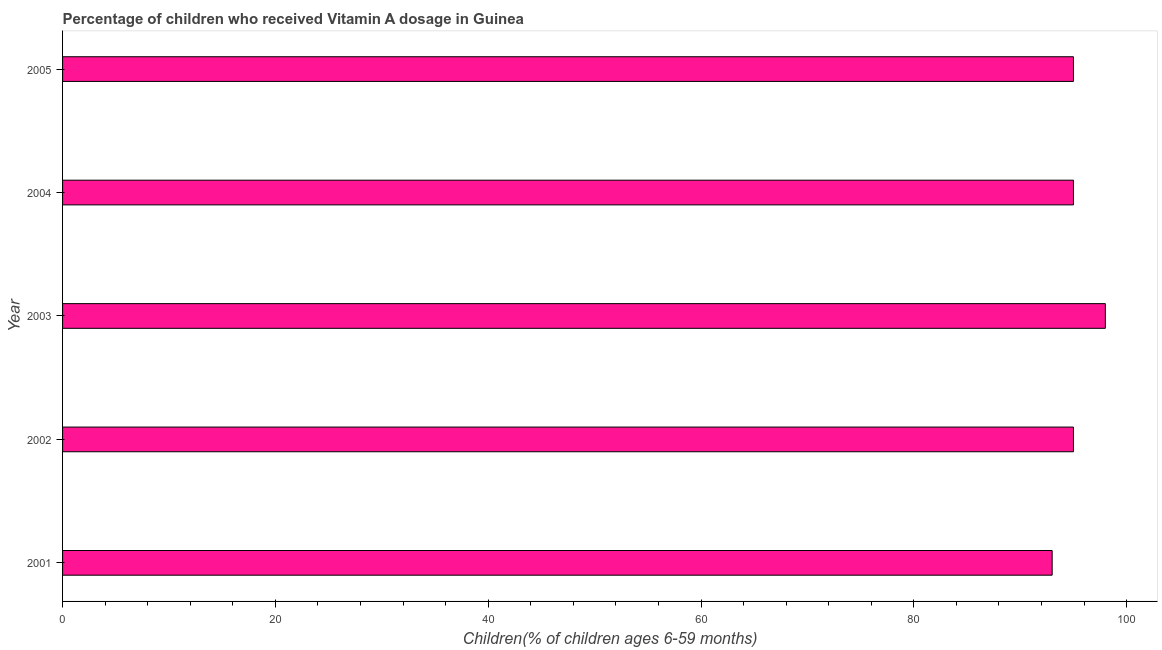Does the graph contain any zero values?
Offer a terse response. No. What is the title of the graph?
Your answer should be compact. Percentage of children who received Vitamin A dosage in Guinea. What is the label or title of the X-axis?
Offer a very short reply. Children(% of children ages 6-59 months). Across all years, what is the minimum vitamin a supplementation coverage rate?
Provide a short and direct response. 93. In which year was the vitamin a supplementation coverage rate minimum?
Ensure brevity in your answer.  2001. What is the sum of the vitamin a supplementation coverage rate?
Keep it short and to the point. 476. What is the difference between the vitamin a supplementation coverage rate in 2002 and 2004?
Your answer should be compact. 0. What is the average vitamin a supplementation coverage rate per year?
Your answer should be very brief. 95.2. What is the median vitamin a supplementation coverage rate?
Ensure brevity in your answer.  95. Do a majority of the years between 2001 and 2005 (inclusive) have vitamin a supplementation coverage rate greater than 60 %?
Provide a short and direct response. Yes. Is the vitamin a supplementation coverage rate in 2002 less than that in 2003?
Provide a succinct answer. Yes. What is the difference between the highest and the lowest vitamin a supplementation coverage rate?
Your answer should be compact. 5. How many bars are there?
Offer a terse response. 5. How many years are there in the graph?
Ensure brevity in your answer.  5. What is the difference between two consecutive major ticks on the X-axis?
Provide a short and direct response. 20. What is the Children(% of children ages 6-59 months) in 2001?
Make the answer very short. 93. What is the difference between the Children(% of children ages 6-59 months) in 2002 and 2003?
Make the answer very short. -3. What is the difference between the Children(% of children ages 6-59 months) in 2002 and 2004?
Offer a very short reply. 0. What is the difference between the Children(% of children ages 6-59 months) in 2003 and 2004?
Make the answer very short. 3. What is the difference between the Children(% of children ages 6-59 months) in 2003 and 2005?
Provide a short and direct response. 3. What is the ratio of the Children(% of children ages 6-59 months) in 2001 to that in 2002?
Provide a short and direct response. 0.98. What is the ratio of the Children(% of children ages 6-59 months) in 2001 to that in 2003?
Offer a very short reply. 0.95. What is the ratio of the Children(% of children ages 6-59 months) in 2002 to that in 2004?
Keep it short and to the point. 1. What is the ratio of the Children(% of children ages 6-59 months) in 2002 to that in 2005?
Provide a short and direct response. 1. What is the ratio of the Children(% of children ages 6-59 months) in 2003 to that in 2004?
Your answer should be compact. 1.03. What is the ratio of the Children(% of children ages 6-59 months) in 2003 to that in 2005?
Make the answer very short. 1.03. What is the ratio of the Children(% of children ages 6-59 months) in 2004 to that in 2005?
Give a very brief answer. 1. 